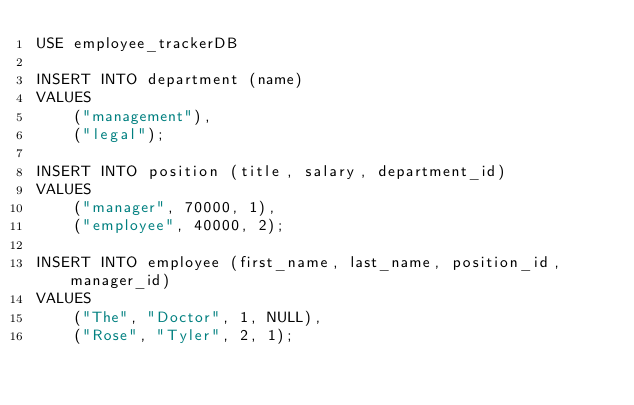<code> <loc_0><loc_0><loc_500><loc_500><_SQL_>USE employee_trackerDB

INSERT INTO department (name)
VALUES
    ("management"),
    ("legal");

INSERT INTO position (title, salary, department_id)
VALUES  
    ("manager", 70000, 1),
    ("employee", 40000, 2);

INSERT INTO employee (first_name, last_name, position_id, manager_id)
VALUES
    ("The", "Doctor", 1, NULL),
    ("Rose", "Tyler", 2, 1);</code> 